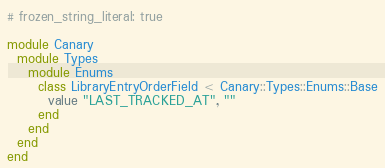Convert code to text. <code><loc_0><loc_0><loc_500><loc_500><_Ruby_># frozen_string_literal: true

module Canary
  module Types
    module Enums
      class LibraryEntryOrderField < Canary::Types::Enums::Base
        value "LAST_TRACKED_AT", ""
      end
    end
  end
end
</code> 